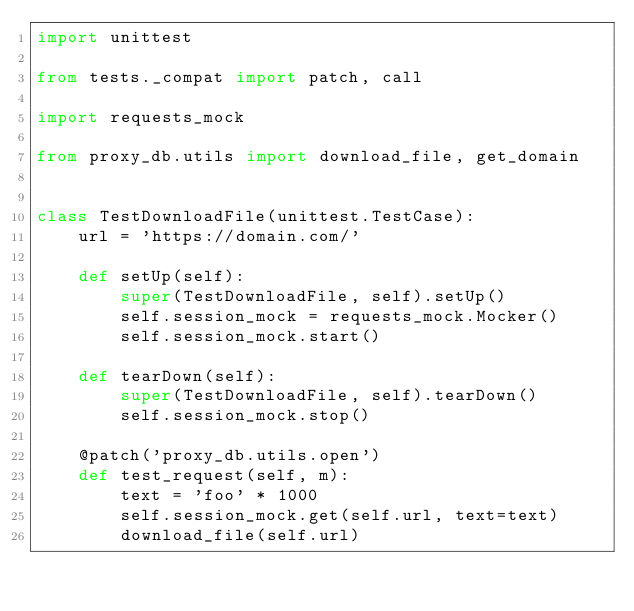<code> <loc_0><loc_0><loc_500><loc_500><_Python_>import unittest

from tests._compat import patch, call

import requests_mock

from proxy_db.utils import download_file, get_domain


class TestDownloadFile(unittest.TestCase):
    url = 'https://domain.com/'

    def setUp(self):
        super(TestDownloadFile, self).setUp()
        self.session_mock = requests_mock.Mocker()
        self.session_mock.start()

    def tearDown(self):
        super(TestDownloadFile, self).tearDown()
        self.session_mock.stop()

    @patch('proxy_db.utils.open')
    def test_request(self, m):
        text = 'foo' * 1000
        self.session_mock.get(self.url, text=text)
        download_file(self.url)</code> 